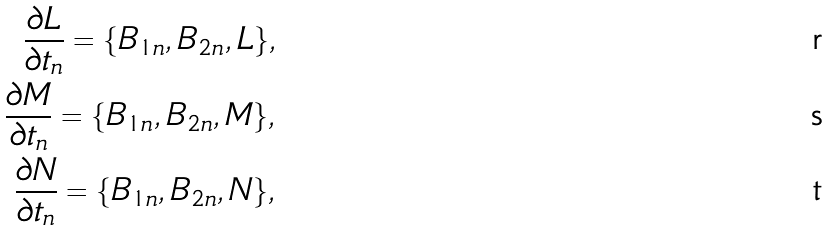<formula> <loc_0><loc_0><loc_500><loc_500>\frac { \partial L } { \partial t _ { n } } = \{ B _ { 1 n } , B _ { 2 n } , L \} , \\ \frac { \partial M } { \partial t _ { n } } = \{ B _ { 1 n } , B _ { 2 n } , M \} , \\ \frac { \partial N } { \partial t _ { n } } = \{ B _ { 1 n } , B _ { 2 n } , N \} ,</formula> 